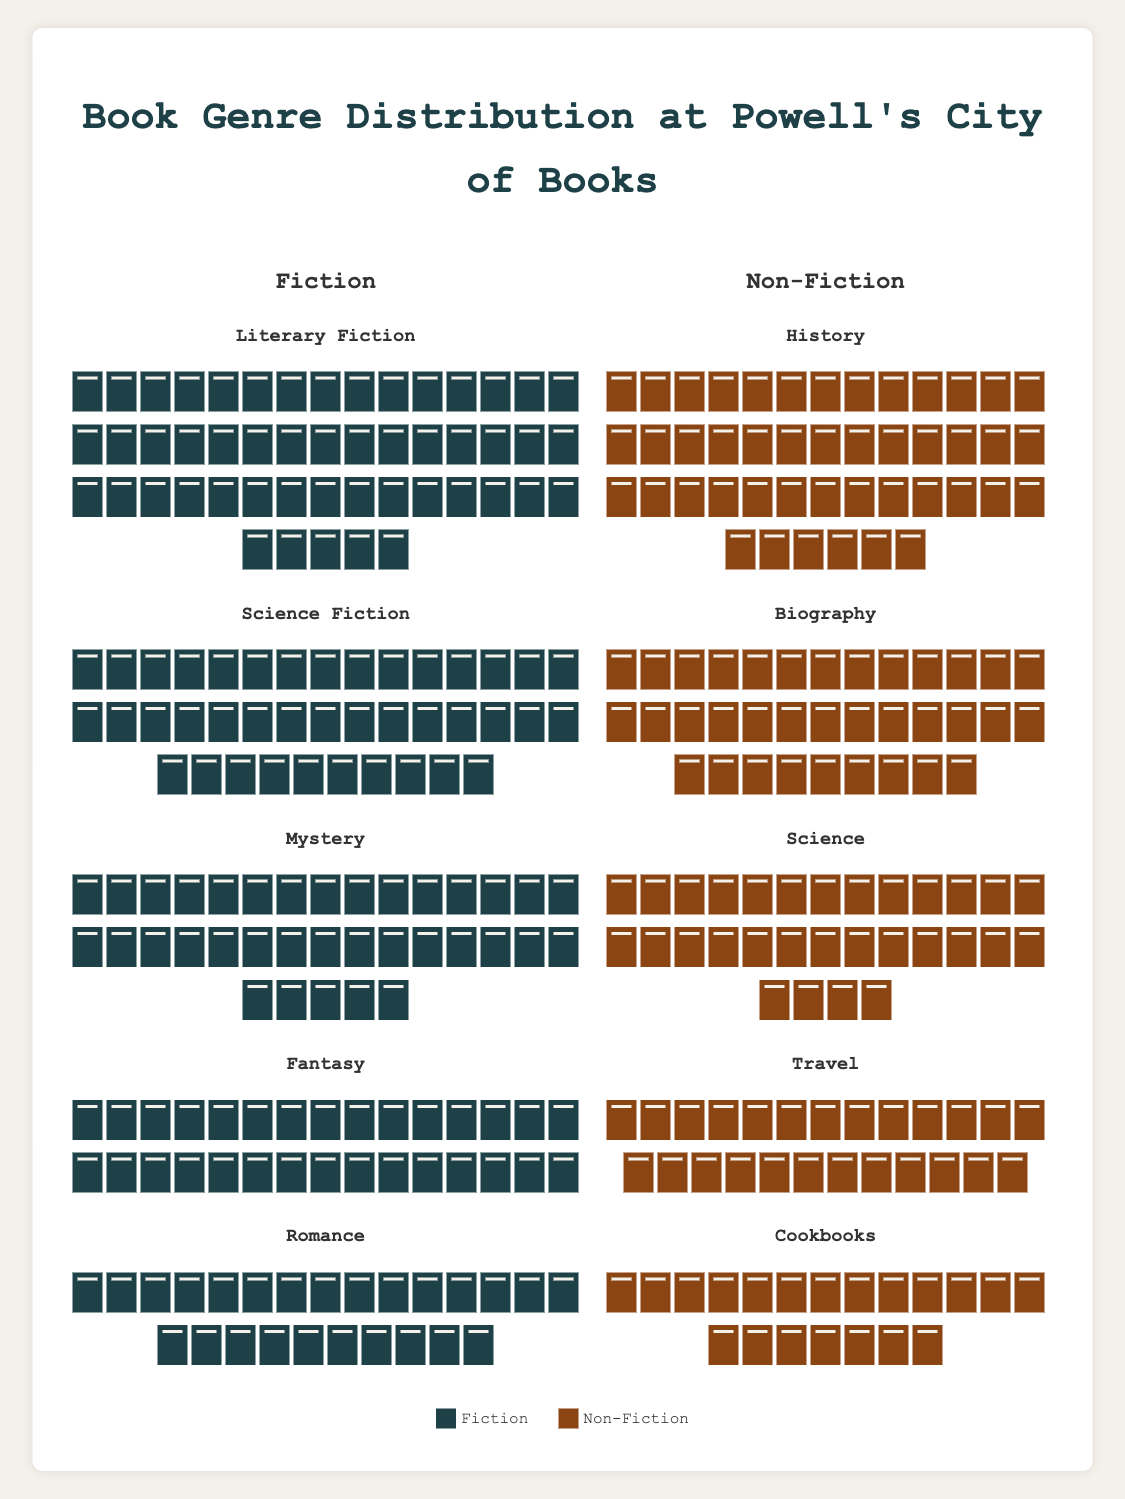What are the two main categories shown in the plot? The plot has two main sections labeled as "Fiction" and "Non-Fiction," indicating the two primary categories of books.
Answer: Fiction and Non-Fiction Which genre under Fiction has the highest count of books? By observing the number of book icons grouped under each genre in the Fiction category, "Literary Fiction" has the highest count with 50 book icons.
Answer: Literary Fiction How many book genres are listed under Non-Fiction? Count the individual genres listed under the Non-Fiction category, which are History, Biography, Science, Travel, and Cookbooks. This gives a total of 5 genres.
Answer: 5 What color are the book icons representing the Fiction category? The book icons under the Fiction category are filled with a greenish color as indicated by the color assigned to the Fiction legend item.
Answer: Greenish What is the combined count of all Science Fiction and Mystery books? Add the count of Science Fiction books (40) and Mystery books (35) together.
Answer: 75 Which Non-Fiction genre has the least number of books, and how many are there? By examining the height and count of book icons in each Non-Fiction genre, "Cookbooks" has the least with 20 book icons.
Answer: Cookbooks, 20 Is the count of books in the Romance genre higher or lower than in the Science genre? Compare the number of book icons in the Romance genre (25) under Fiction to the Science genre (30) under Non-Fiction, which shows that the number for Romance is lower.
Answer: Lower Are there more total books in the Fiction category or Non-Fiction category? Sum the book counts for each genre in Fiction (50 + 40 + 35 + 30 + 25 = 180) and Non-Fiction (45 + 35 + 30 + 25 + 20 = 155) and compare.
Answer: Fiction What is the average count of books per genre for the Non-Fiction category? Calculate the average by summing the counts of the genres in Non-Fiction (45 + 35 + 30 + 25 + 20 = 155) and dividing by the number of genres (5).
Answer: 31 Which genre has more books, Fantasy or Travel, and by how many? Compare the counts of Fantasy books (30) and Travel books (25), and subtract the lower count from the higher count (30 - 25).
Answer: Fantasy, 5 